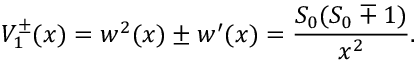<formula> <loc_0><loc_0><loc_500><loc_500>V _ { 1 } ^ { \pm } ( x ) = w ^ { 2 } ( x ) \pm w ^ { \prime } ( x ) = \frac { S _ { 0 } ( S _ { 0 } \mp 1 ) } { x ^ { 2 } } .</formula> 